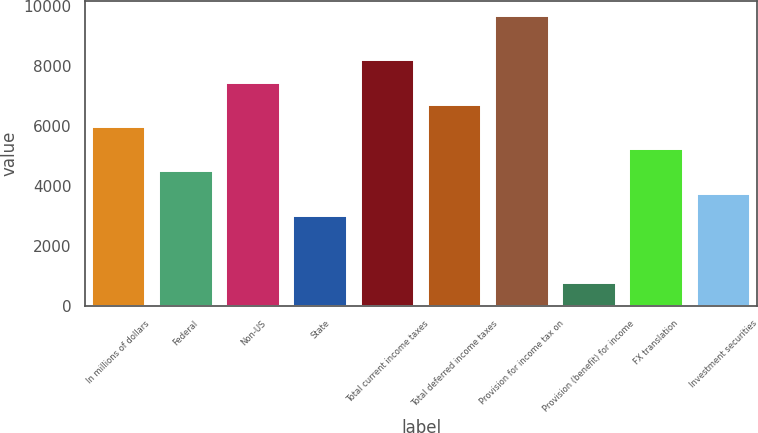Convert chart to OTSL. <chart><loc_0><loc_0><loc_500><loc_500><bar_chart><fcel>In millions of dollars<fcel>Federal<fcel>Non-US<fcel>State<fcel>Total current income taxes<fcel>Total deferred income taxes<fcel>Provision for income tax on<fcel>Provision (benefit) for income<fcel>FX translation<fcel>Investment securities<nl><fcel>5956.8<fcel>4473.6<fcel>7440<fcel>2990.4<fcel>8181.6<fcel>6698.4<fcel>9664.8<fcel>765.6<fcel>5215.2<fcel>3732<nl></chart> 